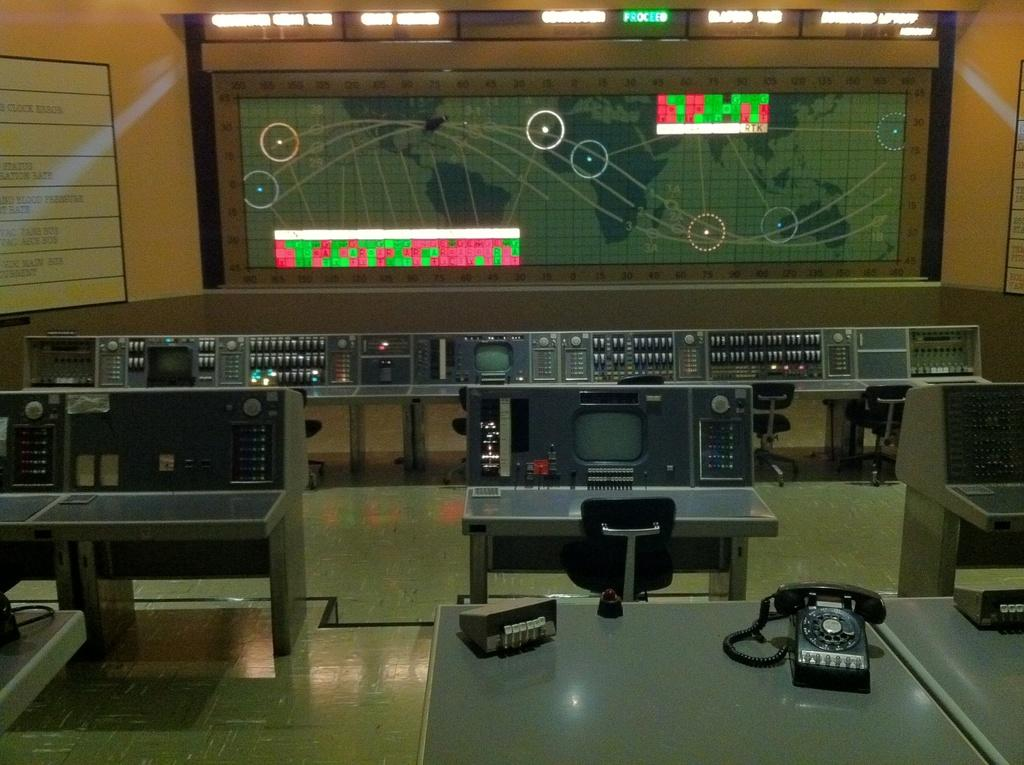What type of objects can be seen in the image? There are devices, desks, chairs, a telephone, and other objects in the image. What can be found on the floor in the image? The floor is visible in the image. What is the background of the image like? There is a wall, boards, and a screen in the background of the image. What type of gold shoes can be seen on the sheep in the image? There are no sheep or gold shoes present in the image. 